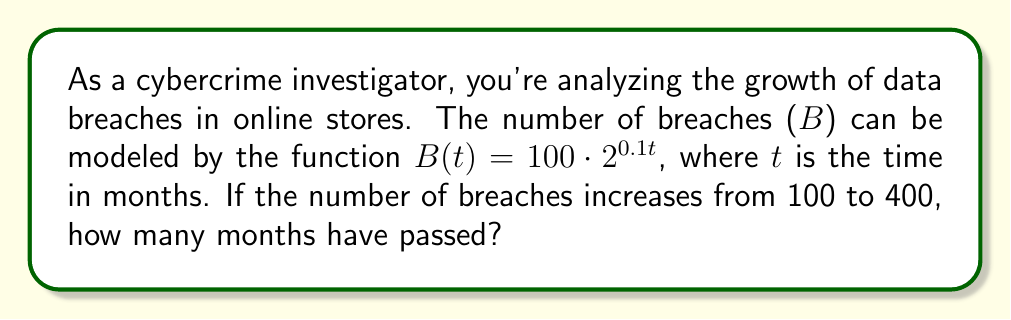Give your solution to this math problem. Let's approach this step-by-step:

1) We're given the function $B(t) = 100 \cdot 2^{0.1t}$

2) We need to find t when B increases from 100 to 400

3) Let's set up an equation:
   $400 = 100 \cdot 2^{0.1t}$

4) Simplify:
   $4 = 2^{0.1t}$

5) Take the logarithm (base 2) of both sides:
   $\log_2(4) = \log_2(2^{0.1t})$

6) Simplify the right side using the logarithm property $\log_a(a^x) = x$:
   $\log_2(4) = 0.1t$

7) Simplify the left side:
   $2 = 0.1t$

8) Solve for t:
   $t = 2 / 0.1 = 20$

Therefore, 20 months have passed.
Answer: 20 months 